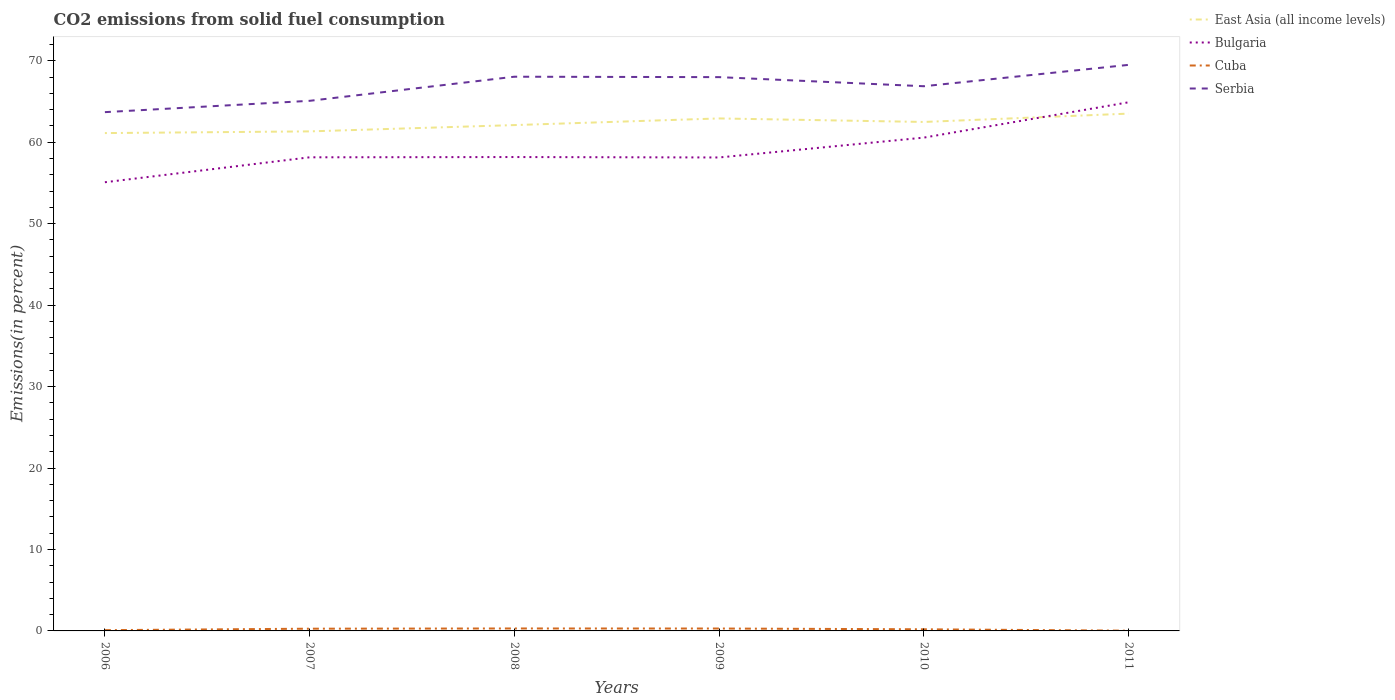How many different coloured lines are there?
Keep it short and to the point. 4. Is the number of lines equal to the number of legend labels?
Your response must be concise. Yes. Across all years, what is the maximum total CO2 emitted in Cuba?
Your response must be concise. 0.03. What is the total total CO2 emitted in Serbia in the graph?
Offer a very short reply. 1.12. What is the difference between the highest and the second highest total CO2 emitted in Cuba?
Provide a succinct answer. 0.27. How many lines are there?
Give a very brief answer. 4. How many years are there in the graph?
Make the answer very short. 6. What is the difference between two consecutive major ticks on the Y-axis?
Make the answer very short. 10. Are the values on the major ticks of Y-axis written in scientific E-notation?
Give a very brief answer. No. Does the graph contain grids?
Offer a terse response. No. Where does the legend appear in the graph?
Ensure brevity in your answer.  Top right. How many legend labels are there?
Provide a succinct answer. 4. How are the legend labels stacked?
Offer a terse response. Vertical. What is the title of the graph?
Offer a very short reply. CO2 emissions from solid fuel consumption. Does "Channel Islands" appear as one of the legend labels in the graph?
Give a very brief answer. No. What is the label or title of the X-axis?
Your response must be concise. Years. What is the label or title of the Y-axis?
Offer a very short reply. Emissions(in percent). What is the Emissions(in percent) in East Asia (all income levels) in 2006?
Keep it short and to the point. 61.12. What is the Emissions(in percent) in Bulgaria in 2006?
Provide a succinct answer. 55.08. What is the Emissions(in percent) of Cuba in 2006?
Make the answer very short. 0.09. What is the Emissions(in percent) of Serbia in 2006?
Your answer should be very brief. 63.69. What is the Emissions(in percent) of East Asia (all income levels) in 2007?
Your response must be concise. 61.33. What is the Emissions(in percent) of Bulgaria in 2007?
Your response must be concise. 58.14. What is the Emissions(in percent) in Cuba in 2007?
Offer a very short reply. 0.27. What is the Emissions(in percent) in Serbia in 2007?
Provide a short and direct response. 65.08. What is the Emissions(in percent) in East Asia (all income levels) in 2008?
Give a very brief answer. 62.1. What is the Emissions(in percent) in Bulgaria in 2008?
Your answer should be compact. 58.18. What is the Emissions(in percent) in Cuba in 2008?
Ensure brevity in your answer.  0.3. What is the Emissions(in percent) of Serbia in 2008?
Offer a terse response. 68.04. What is the Emissions(in percent) in East Asia (all income levels) in 2009?
Offer a very short reply. 62.92. What is the Emissions(in percent) in Bulgaria in 2009?
Your answer should be compact. 58.12. What is the Emissions(in percent) of Cuba in 2009?
Keep it short and to the point. 0.29. What is the Emissions(in percent) of Serbia in 2009?
Offer a very short reply. 67.99. What is the Emissions(in percent) in East Asia (all income levels) in 2010?
Provide a short and direct response. 62.48. What is the Emissions(in percent) of Bulgaria in 2010?
Your response must be concise. 60.56. What is the Emissions(in percent) of Cuba in 2010?
Keep it short and to the point. 0.2. What is the Emissions(in percent) in Serbia in 2010?
Offer a terse response. 66.87. What is the Emissions(in percent) of East Asia (all income levels) in 2011?
Offer a terse response. 63.51. What is the Emissions(in percent) of Bulgaria in 2011?
Your answer should be compact. 64.9. What is the Emissions(in percent) in Cuba in 2011?
Offer a terse response. 0.03. What is the Emissions(in percent) of Serbia in 2011?
Ensure brevity in your answer.  69.49. Across all years, what is the maximum Emissions(in percent) of East Asia (all income levels)?
Offer a terse response. 63.51. Across all years, what is the maximum Emissions(in percent) of Bulgaria?
Your answer should be very brief. 64.9. Across all years, what is the maximum Emissions(in percent) of Cuba?
Give a very brief answer. 0.3. Across all years, what is the maximum Emissions(in percent) in Serbia?
Offer a very short reply. 69.49. Across all years, what is the minimum Emissions(in percent) of East Asia (all income levels)?
Offer a terse response. 61.12. Across all years, what is the minimum Emissions(in percent) of Bulgaria?
Offer a terse response. 55.08. Across all years, what is the minimum Emissions(in percent) of Cuba?
Ensure brevity in your answer.  0.03. Across all years, what is the minimum Emissions(in percent) of Serbia?
Ensure brevity in your answer.  63.69. What is the total Emissions(in percent) of East Asia (all income levels) in the graph?
Make the answer very short. 373.45. What is the total Emissions(in percent) in Bulgaria in the graph?
Offer a very short reply. 354.99. What is the total Emissions(in percent) of Cuba in the graph?
Make the answer very short. 1.19. What is the total Emissions(in percent) of Serbia in the graph?
Offer a terse response. 401.15. What is the difference between the Emissions(in percent) of East Asia (all income levels) in 2006 and that in 2007?
Your answer should be very brief. -0.21. What is the difference between the Emissions(in percent) in Bulgaria in 2006 and that in 2007?
Offer a very short reply. -3.06. What is the difference between the Emissions(in percent) of Cuba in 2006 and that in 2007?
Ensure brevity in your answer.  -0.18. What is the difference between the Emissions(in percent) of Serbia in 2006 and that in 2007?
Ensure brevity in your answer.  -1.39. What is the difference between the Emissions(in percent) in East Asia (all income levels) in 2006 and that in 2008?
Give a very brief answer. -0.98. What is the difference between the Emissions(in percent) in Bulgaria in 2006 and that in 2008?
Ensure brevity in your answer.  -3.09. What is the difference between the Emissions(in percent) in Cuba in 2006 and that in 2008?
Provide a short and direct response. -0.21. What is the difference between the Emissions(in percent) of Serbia in 2006 and that in 2008?
Provide a succinct answer. -4.35. What is the difference between the Emissions(in percent) of East Asia (all income levels) in 2006 and that in 2009?
Keep it short and to the point. -1.8. What is the difference between the Emissions(in percent) of Bulgaria in 2006 and that in 2009?
Keep it short and to the point. -3.04. What is the difference between the Emissions(in percent) of Cuba in 2006 and that in 2009?
Provide a short and direct response. -0.2. What is the difference between the Emissions(in percent) in Serbia in 2006 and that in 2009?
Give a very brief answer. -4.3. What is the difference between the Emissions(in percent) of East Asia (all income levels) in 2006 and that in 2010?
Provide a succinct answer. -1.37. What is the difference between the Emissions(in percent) in Bulgaria in 2006 and that in 2010?
Your answer should be compact. -5.48. What is the difference between the Emissions(in percent) in Cuba in 2006 and that in 2010?
Provide a short and direct response. -0.11. What is the difference between the Emissions(in percent) of Serbia in 2006 and that in 2010?
Your response must be concise. -3.18. What is the difference between the Emissions(in percent) of East Asia (all income levels) in 2006 and that in 2011?
Keep it short and to the point. -2.39. What is the difference between the Emissions(in percent) of Bulgaria in 2006 and that in 2011?
Ensure brevity in your answer.  -9.81. What is the difference between the Emissions(in percent) in Cuba in 2006 and that in 2011?
Offer a very short reply. 0.06. What is the difference between the Emissions(in percent) of Serbia in 2006 and that in 2011?
Provide a succinct answer. -5.8. What is the difference between the Emissions(in percent) of East Asia (all income levels) in 2007 and that in 2008?
Offer a terse response. -0.77. What is the difference between the Emissions(in percent) in Bulgaria in 2007 and that in 2008?
Your answer should be compact. -0.03. What is the difference between the Emissions(in percent) of Cuba in 2007 and that in 2008?
Provide a short and direct response. -0.03. What is the difference between the Emissions(in percent) of Serbia in 2007 and that in 2008?
Provide a short and direct response. -2.96. What is the difference between the Emissions(in percent) of East Asia (all income levels) in 2007 and that in 2009?
Offer a terse response. -1.59. What is the difference between the Emissions(in percent) in Bulgaria in 2007 and that in 2009?
Give a very brief answer. 0.02. What is the difference between the Emissions(in percent) in Cuba in 2007 and that in 2009?
Ensure brevity in your answer.  -0.02. What is the difference between the Emissions(in percent) in Serbia in 2007 and that in 2009?
Offer a very short reply. -2.91. What is the difference between the Emissions(in percent) in East Asia (all income levels) in 2007 and that in 2010?
Your answer should be compact. -1.16. What is the difference between the Emissions(in percent) in Bulgaria in 2007 and that in 2010?
Provide a succinct answer. -2.42. What is the difference between the Emissions(in percent) in Cuba in 2007 and that in 2010?
Your answer should be very brief. 0.07. What is the difference between the Emissions(in percent) in Serbia in 2007 and that in 2010?
Keep it short and to the point. -1.79. What is the difference between the Emissions(in percent) of East Asia (all income levels) in 2007 and that in 2011?
Provide a succinct answer. -2.18. What is the difference between the Emissions(in percent) of Bulgaria in 2007 and that in 2011?
Your answer should be very brief. -6.75. What is the difference between the Emissions(in percent) in Cuba in 2007 and that in 2011?
Give a very brief answer. 0.24. What is the difference between the Emissions(in percent) in Serbia in 2007 and that in 2011?
Provide a succinct answer. -4.41. What is the difference between the Emissions(in percent) of East Asia (all income levels) in 2008 and that in 2009?
Provide a short and direct response. -0.82. What is the difference between the Emissions(in percent) of Bulgaria in 2008 and that in 2009?
Your answer should be very brief. 0.05. What is the difference between the Emissions(in percent) in Cuba in 2008 and that in 2009?
Provide a succinct answer. 0.01. What is the difference between the Emissions(in percent) in Serbia in 2008 and that in 2009?
Make the answer very short. 0.05. What is the difference between the Emissions(in percent) in East Asia (all income levels) in 2008 and that in 2010?
Your answer should be very brief. -0.38. What is the difference between the Emissions(in percent) of Bulgaria in 2008 and that in 2010?
Ensure brevity in your answer.  -2.39. What is the difference between the Emissions(in percent) in Cuba in 2008 and that in 2010?
Give a very brief answer. 0.1. What is the difference between the Emissions(in percent) in Serbia in 2008 and that in 2010?
Your answer should be very brief. 1.17. What is the difference between the Emissions(in percent) of East Asia (all income levels) in 2008 and that in 2011?
Your response must be concise. -1.41. What is the difference between the Emissions(in percent) in Bulgaria in 2008 and that in 2011?
Your answer should be compact. -6.72. What is the difference between the Emissions(in percent) of Cuba in 2008 and that in 2011?
Your response must be concise. 0.27. What is the difference between the Emissions(in percent) of Serbia in 2008 and that in 2011?
Provide a succinct answer. -1.45. What is the difference between the Emissions(in percent) in East Asia (all income levels) in 2009 and that in 2010?
Your answer should be compact. 0.43. What is the difference between the Emissions(in percent) of Bulgaria in 2009 and that in 2010?
Your response must be concise. -2.44. What is the difference between the Emissions(in percent) in Cuba in 2009 and that in 2010?
Offer a terse response. 0.09. What is the difference between the Emissions(in percent) in Serbia in 2009 and that in 2010?
Ensure brevity in your answer.  1.12. What is the difference between the Emissions(in percent) of East Asia (all income levels) in 2009 and that in 2011?
Your answer should be very brief. -0.59. What is the difference between the Emissions(in percent) in Bulgaria in 2009 and that in 2011?
Offer a terse response. -6.77. What is the difference between the Emissions(in percent) in Cuba in 2009 and that in 2011?
Your answer should be very brief. 0.26. What is the difference between the Emissions(in percent) of Serbia in 2009 and that in 2011?
Provide a succinct answer. -1.51. What is the difference between the Emissions(in percent) in East Asia (all income levels) in 2010 and that in 2011?
Keep it short and to the point. -1.02. What is the difference between the Emissions(in percent) of Bulgaria in 2010 and that in 2011?
Offer a terse response. -4.34. What is the difference between the Emissions(in percent) of Cuba in 2010 and that in 2011?
Provide a short and direct response. 0.17. What is the difference between the Emissions(in percent) of Serbia in 2010 and that in 2011?
Make the answer very short. -2.62. What is the difference between the Emissions(in percent) of East Asia (all income levels) in 2006 and the Emissions(in percent) of Bulgaria in 2007?
Offer a terse response. 2.97. What is the difference between the Emissions(in percent) in East Asia (all income levels) in 2006 and the Emissions(in percent) in Cuba in 2007?
Ensure brevity in your answer.  60.84. What is the difference between the Emissions(in percent) in East Asia (all income levels) in 2006 and the Emissions(in percent) in Serbia in 2007?
Offer a terse response. -3.96. What is the difference between the Emissions(in percent) of Bulgaria in 2006 and the Emissions(in percent) of Cuba in 2007?
Make the answer very short. 54.81. What is the difference between the Emissions(in percent) in Bulgaria in 2006 and the Emissions(in percent) in Serbia in 2007?
Offer a very short reply. -9.99. What is the difference between the Emissions(in percent) in Cuba in 2006 and the Emissions(in percent) in Serbia in 2007?
Provide a short and direct response. -64.98. What is the difference between the Emissions(in percent) in East Asia (all income levels) in 2006 and the Emissions(in percent) in Bulgaria in 2008?
Offer a very short reply. 2.94. What is the difference between the Emissions(in percent) in East Asia (all income levels) in 2006 and the Emissions(in percent) in Cuba in 2008?
Offer a very short reply. 60.82. What is the difference between the Emissions(in percent) in East Asia (all income levels) in 2006 and the Emissions(in percent) in Serbia in 2008?
Your response must be concise. -6.92. What is the difference between the Emissions(in percent) of Bulgaria in 2006 and the Emissions(in percent) of Cuba in 2008?
Your answer should be very brief. 54.78. What is the difference between the Emissions(in percent) in Bulgaria in 2006 and the Emissions(in percent) in Serbia in 2008?
Your answer should be compact. -12.95. What is the difference between the Emissions(in percent) in Cuba in 2006 and the Emissions(in percent) in Serbia in 2008?
Provide a short and direct response. -67.94. What is the difference between the Emissions(in percent) of East Asia (all income levels) in 2006 and the Emissions(in percent) of Bulgaria in 2009?
Your answer should be very brief. 2.99. What is the difference between the Emissions(in percent) in East Asia (all income levels) in 2006 and the Emissions(in percent) in Cuba in 2009?
Make the answer very short. 60.82. What is the difference between the Emissions(in percent) in East Asia (all income levels) in 2006 and the Emissions(in percent) in Serbia in 2009?
Offer a very short reply. -6.87. What is the difference between the Emissions(in percent) of Bulgaria in 2006 and the Emissions(in percent) of Cuba in 2009?
Give a very brief answer. 54.79. What is the difference between the Emissions(in percent) of Bulgaria in 2006 and the Emissions(in percent) of Serbia in 2009?
Your response must be concise. -12.9. What is the difference between the Emissions(in percent) in Cuba in 2006 and the Emissions(in percent) in Serbia in 2009?
Provide a short and direct response. -67.89. What is the difference between the Emissions(in percent) in East Asia (all income levels) in 2006 and the Emissions(in percent) in Bulgaria in 2010?
Offer a very short reply. 0.56. What is the difference between the Emissions(in percent) in East Asia (all income levels) in 2006 and the Emissions(in percent) in Cuba in 2010?
Provide a succinct answer. 60.92. What is the difference between the Emissions(in percent) of East Asia (all income levels) in 2006 and the Emissions(in percent) of Serbia in 2010?
Offer a very short reply. -5.75. What is the difference between the Emissions(in percent) of Bulgaria in 2006 and the Emissions(in percent) of Cuba in 2010?
Provide a succinct answer. 54.88. What is the difference between the Emissions(in percent) of Bulgaria in 2006 and the Emissions(in percent) of Serbia in 2010?
Give a very brief answer. -11.79. What is the difference between the Emissions(in percent) of Cuba in 2006 and the Emissions(in percent) of Serbia in 2010?
Your response must be concise. -66.78. What is the difference between the Emissions(in percent) of East Asia (all income levels) in 2006 and the Emissions(in percent) of Bulgaria in 2011?
Make the answer very short. -3.78. What is the difference between the Emissions(in percent) in East Asia (all income levels) in 2006 and the Emissions(in percent) in Cuba in 2011?
Provide a short and direct response. 61.09. What is the difference between the Emissions(in percent) in East Asia (all income levels) in 2006 and the Emissions(in percent) in Serbia in 2011?
Provide a short and direct response. -8.37. What is the difference between the Emissions(in percent) of Bulgaria in 2006 and the Emissions(in percent) of Cuba in 2011?
Keep it short and to the point. 55.05. What is the difference between the Emissions(in percent) of Bulgaria in 2006 and the Emissions(in percent) of Serbia in 2011?
Provide a short and direct response. -14.41. What is the difference between the Emissions(in percent) of Cuba in 2006 and the Emissions(in percent) of Serbia in 2011?
Give a very brief answer. -69.4. What is the difference between the Emissions(in percent) in East Asia (all income levels) in 2007 and the Emissions(in percent) in Bulgaria in 2008?
Ensure brevity in your answer.  3.15. What is the difference between the Emissions(in percent) in East Asia (all income levels) in 2007 and the Emissions(in percent) in Cuba in 2008?
Your answer should be very brief. 61.02. What is the difference between the Emissions(in percent) of East Asia (all income levels) in 2007 and the Emissions(in percent) of Serbia in 2008?
Ensure brevity in your answer.  -6.71. What is the difference between the Emissions(in percent) in Bulgaria in 2007 and the Emissions(in percent) in Cuba in 2008?
Offer a terse response. 57.84. What is the difference between the Emissions(in percent) of Bulgaria in 2007 and the Emissions(in percent) of Serbia in 2008?
Your answer should be very brief. -9.89. What is the difference between the Emissions(in percent) in Cuba in 2007 and the Emissions(in percent) in Serbia in 2008?
Provide a succinct answer. -67.76. What is the difference between the Emissions(in percent) of East Asia (all income levels) in 2007 and the Emissions(in percent) of Bulgaria in 2009?
Provide a succinct answer. 3.2. What is the difference between the Emissions(in percent) of East Asia (all income levels) in 2007 and the Emissions(in percent) of Cuba in 2009?
Provide a short and direct response. 61.03. What is the difference between the Emissions(in percent) of East Asia (all income levels) in 2007 and the Emissions(in percent) of Serbia in 2009?
Offer a very short reply. -6.66. What is the difference between the Emissions(in percent) in Bulgaria in 2007 and the Emissions(in percent) in Cuba in 2009?
Keep it short and to the point. 57.85. What is the difference between the Emissions(in percent) in Bulgaria in 2007 and the Emissions(in percent) in Serbia in 2009?
Your answer should be very brief. -9.84. What is the difference between the Emissions(in percent) in Cuba in 2007 and the Emissions(in percent) in Serbia in 2009?
Give a very brief answer. -67.71. What is the difference between the Emissions(in percent) in East Asia (all income levels) in 2007 and the Emissions(in percent) in Bulgaria in 2010?
Keep it short and to the point. 0.76. What is the difference between the Emissions(in percent) in East Asia (all income levels) in 2007 and the Emissions(in percent) in Cuba in 2010?
Your response must be concise. 61.12. What is the difference between the Emissions(in percent) of East Asia (all income levels) in 2007 and the Emissions(in percent) of Serbia in 2010?
Your answer should be compact. -5.54. What is the difference between the Emissions(in percent) in Bulgaria in 2007 and the Emissions(in percent) in Cuba in 2010?
Give a very brief answer. 57.94. What is the difference between the Emissions(in percent) of Bulgaria in 2007 and the Emissions(in percent) of Serbia in 2010?
Make the answer very short. -8.73. What is the difference between the Emissions(in percent) of Cuba in 2007 and the Emissions(in percent) of Serbia in 2010?
Make the answer very short. -66.6. What is the difference between the Emissions(in percent) of East Asia (all income levels) in 2007 and the Emissions(in percent) of Bulgaria in 2011?
Your answer should be compact. -3.57. What is the difference between the Emissions(in percent) in East Asia (all income levels) in 2007 and the Emissions(in percent) in Cuba in 2011?
Provide a short and direct response. 61.3. What is the difference between the Emissions(in percent) of East Asia (all income levels) in 2007 and the Emissions(in percent) of Serbia in 2011?
Provide a succinct answer. -8.17. What is the difference between the Emissions(in percent) of Bulgaria in 2007 and the Emissions(in percent) of Cuba in 2011?
Your response must be concise. 58.11. What is the difference between the Emissions(in percent) in Bulgaria in 2007 and the Emissions(in percent) in Serbia in 2011?
Provide a succinct answer. -11.35. What is the difference between the Emissions(in percent) in Cuba in 2007 and the Emissions(in percent) in Serbia in 2011?
Provide a short and direct response. -69.22. What is the difference between the Emissions(in percent) in East Asia (all income levels) in 2008 and the Emissions(in percent) in Bulgaria in 2009?
Give a very brief answer. 3.98. What is the difference between the Emissions(in percent) of East Asia (all income levels) in 2008 and the Emissions(in percent) of Cuba in 2009?
Your answer should be very brief. 61.81. What is the difference between the Emissions(in percent) in East Asia (all income levels) in 2008 and the Emissions(in percent) in Serbia in 2009?
Ensure brevity in your answer.  -5.89. What is the difference between the Emissions(in percent) of Bulgaria in 2008 and the Emissions(in percent) of Cuba in 2009?
Offer a very short reply. 57.88. What is the difference between the Emissions(in percent) of Bulgaria in 2008 and the Emissions(in percent) of Serbia in 2009?
Provide a short and direct response. -9.81. What is the difference between the Emissions(in percent) in Cuba in 2008 and the Emissions(in percent) in Serbia in 2009?
Offer a very short reply. -67.69. What is the difference between the Emissions(in percent) of East Asia (all income levels) in 2008 and the Emissions(in percent) of Bulgaria in 2010?
Your answer should be compact. 1.54. What is the difference between the Emissions(in percent) of East Asia (all income levels) in 2008 and the Emissions(in percent) of Cuba in 2010?
Your answer should be compact. 61.9. What is the difference between the Emissions(in percent) of East Asia (all income levels) in 2008 and the Emissions(in percent) of Serbia in 2010?
Your answer should be compact. -4.77. What is the difference between the Emissions(in percent) in Bulgaria in 2008 and the Emissions(in percent) in Cuba in 2010?
Offer a terse response. 57.98. What is the difference between the Emissions(in percent) in Bulgaria in 2008 and the Emissions(in percent) in Serbia in 2010?
Make the answer very short. -8.69. What is the difference between the Emissions(in percent) of Cuba in 2008 and the Emissions(in percent) of Serbia in 2010?
Provide a succinct answer. -66.57. What is the difference between the Emissions(in percent) of East Asia (all income levels) in 2008 and the Emissions(in percent) of Bulgaria in 2011?
Your answer should be very brief. -2.8. What is the difference between the Emissions(in percent) in East Asia (all income levels) in 2008 and the Emissions(in percent) in Cuba in 2011?
Provide a succinct answer. 62.07. What is the difference between the Emissions(in percent) of East Asia (all income levels) in 2008 and the Emissions(in percent) of Serbia in 2011?
Offer a terse response. -7.39. What is the difference between the Emissions(in percent) of Bulgaria in 2008 and the Emissions(in percent) of Cuba in 2011?
Your response must be concise. 58.15. What is the difference between the Emissions(in percent) in Bulgaria in 2008 and the Emissions(in percent) in Serbia in 2011?
Offer a terse response. -11.32. What is the difference between the Emissions(in percent) in Cuba in 2008 and the Emissions(in percent) in Serbia in 2011?
Ensure brevity in your answer.  -69.19. What is the difference between the Emissions(in percent) in East Asia (all income levels) in 2009 and the Emissions(in percent) in Bulgaria in 2010?
Offer a very short reply. 2.35. What is the difference between the Emissions(in percent) in East Asia (all income levels) in 2009 and the Emissions(in percent) in Cuba in 2010?
Give a very brief answer. 62.71. What is the difference between the Emissions(in percent) of East Asia (all income levels) in 2009 and the Emissions(in percent) of Serbia in 2010?
Give a very brief answer. -3.95. What is the difference between the Emissions(in percent) of Bulgaria in 2009 and the Emissions(in percent) of Cuba in 2010?
Give a very brief answer. 57.92. What is the difference between the Emissions(in percent) of Bulgaria in 2009 and the Emissions(in percent) of Serbia in 2010?
Your answer should be very brief. -8.74. What is the difference between the Emissions(in percent) of Cuba in 2009 and the Emissions(in percent) of Serbia in 2010?
Your answer should be very brief. -66.57. What is the difference between the Emissions(in percent) of East Asia (all income levels) in 2009 and the Emissions(in percent) of Bulgaria in 2011?
Provide a succinct answer. -1.98. What is the difference between the Emissions(in percent) of East Asia (all income levels) in 2009 and the Emissions(in percent) of Cuba in 2011?
Offer a terse response. 62.88. What is the difference between the Emissions(in percent) of East Asia (all income levels) in 2009 and the Emissions(in percent) of Serbia in 2011?
Keep it short and to the point. -6.58. What is the difference between the Emissions(in percent) of Bulgaria in 2009 and the Emissions(in percent) of Cuba in 2011?
Offer a terse response. 58.09. What is the difference between the Emissions(in percent) in Bulgaria in 2009 and the Emissions(in percent) in Serbia in 2011?
Offer a very short reply. -11.37. What is the difference between the Emissions(in percent) in Cuba in 2009 and the Emissions(in percent) in Serbia in 2011?
Offer a very short reply. -69.2. What is the difference between the Emissions(in percent) of East Asia (all income levels) in 2010 and the Emissions(in percent) of Bulgaria in 2011?
Your response must be concise. -2.41. What is the difference between the Emissions(in percent) of East Asia (all income levels) in 2010 and the Emissions(in percent) of Cuba in 2011?
Your response must be concise. 62.45. What is the difference between the Emissions(in percent) in East Asia (all income levels) in 2010 and the Emissions(in percent) in Serbia in 2011?
Your response must be concise. -7.01. What is the difference between the Emissions(in percent) in Bulgaria in 2010 and the Emissions(in percent) in Cuba in 2011?
Provide a short and direct response. 60.53. What is the difference between the Emissions(in percent) of Bulgaria in 2010 and the Emissions(in percent) of Serbia in 2011?
Your answer should be compact. -8.93. What is the difference between the Emissions(in percent) of Cuba in 2010 and the Emissions(in percent) of Serbia in 2011?
Make the answer very short. -69.29. What is the average Emissions(in percent) in East Asia (all income levels) per year?
Give a very brief answer. 62.24. What is the average Emissions(in percent) in Bulgaria per year?
Your answer should be very brief. 59.16. What is the average Emissions(in percent) of Cuba per year?
Your answer should be very brief. 0.2. What is the average Emissions(in percent) in Serbia per year?
Your response must be concise. 66.86. In the year 2006, what is the difference between the Emissions(in percent) in East Asia (all income levels) and Emissions(in percent) in Bulgaria?
Offer a terse response. 6.03. In the year 2006, what is the difference between the Emissions(in percent) in East Asia (all income levels) and Emissions(in percent) in Cuba?
Offer a very short reply. 61.02. In the year 2006, what is the difference between the Emissions(in percent) of East Asia (all income levels) and Emissions(in percent) of Serbia?
Provide a succinct answer. -2.57. In the year 2006, what is the difference between the Emissions(in percent) of Bulgaria and Emissions(in percent) of Cuba?
Offer a very short reply. 54.99. In the year 2006, what is the difference between the Emissions(in percent) of Bulgaria and Emissions(in percent) of Serbia?
Make the answer very short. -8.6. In the year 2006, what is the difference between the Emissions(in percent) of Cuba and Emissions(in percent) of Serbia?
Keep it short and to the point. -63.59. In the year 2007, what is the difference between the Emissions(in percent) in East Asia (all income levels) and Emissions(in percent) in Bulgaria?
Provide a succinct answer. 3.18. In the year 2007, what is the difference between the Emissions(in percent) in East Asia (all income levels) and Emissions(in percent) in Cuba?
Give a very brief answer. 61.05. In the year 2007, what is the difference between the Emissions(in percent) of East Asia (all income levels) and Emissions(in percent) of Serbia?
Offer a very short reply. -3.75. In the year 2007, what is the difference between the Emissions(in percent) of Bulgaria and Emissions(in percent) of Cuba?
Provide a succinct answer. 57.87. In the year 2007, what is the difference between the Emissions(in percent) in Bulgaria and Emissions(in percent) in Serbia?
Provide a succinct answer. -6.93. In the year 2007, what is the difference between the Emissions(in percent) in Cuba and Emissions(in percent) in Serbia?
Make the answer very short. -64.8. In the year 2008, what is the difference between the Emissions(in percent) in East Asia (all income levels) and Emissions(in percent) in Bulgaria?
Your answer should be compact. 3.92. In the year 2008, what is the difference between the Emissions(in percent) of East Asia (all income levels) and Emissions(in percent) of Cuba?
Ensure brevity in your answer.  61.8. In the year 2008, what is the difference between the Emissions(in percent) of East Asia (all income levels) and Emissions(in percent) of Serbia?
Provide a succinct answer. -5.94. In the year 2008, what is the difference between the Emissions(in percent) in Bulgaria and Emissions(in percent) in Cuba?
Your answer should be very brief. 57.88. In the year 2008, what is the difference between the Emissions(in percent) in Bulgaria and Emissions(in percent) in Serbia?
Make the answer very short. -9.86. In the year 2008, what is the difference between the Emissions(in percent) in Cuba and Emissions(in percent) in Serbia?
Provide a succinct answer. -67.74. In the year 2009, what is the difference between the Emissions(in percent) of East Asia (all income levels) and Emissions(in percent) of Bulgaria?
Make the answer very short. 4.79. In the year 2009, what is the difference between the Emissions(in percent) in East Asia (all income levels) and Emissions(in percent) in Cuba?
Offer a very short reply. 62.62. In the year 2009, what is the difference between the Emissions(in percent) in East Asia (all income levels) and Emissions(in percent) in Serbia?
Offer a terse response. -5.07. In the year 2009, what is the difference between the Emissions(in percent) in Bulgaria and Emissions(in percent) in Cuba?
Ensure brevity in your answer.  57.83. In the year 2009, what is the difference between the Emissions(in percent) of Bulgaria and Emissions(in percent) of Serbia?
Offer a terse response. -9.86. In the year 2009, what is the difference between the Emissions(in percent) of Cuba and Emissions(in percent) of Serbia?
Offer a very short reply. -67.69. In the year 2010, what is the difference between the Emissions(in percent) in East Asia (all income levels) and Emissions(in percent) in Bulgaria?
Your answer should be compact. 1.92. In the year 2010, what is the difference between the Emissions(in percent) of East Asia (all income levels) and Emissions(in percent) of Cuba?
Offer a very short reply. 62.28. In the year 2010, what is the difference between the Emissions(in percent) of East Asia (all income levels) and Emissions(in percent) of Serbia?
Your response must be concise. -4.39. In the year 2010, what is the difference between the Emissions(in percent) of Bulgaria and Emissions(in percent) of Cuba?
Provide a short and direct response. 60.36. In the year 2010, what is the difference between the Emissions(in percent) of Bulgaria and Emissions(in percent) of Serbia?
Your answer should be compact. -6.31. In the year 2010, what is the difference between the Emissions(in percent) of Cuba and Emissions(in percent) of Serbia?
Ensure brevity in your answer.  -66.67. In the year 2011, what is the difference between the Emissions(in percent) of East Asia (all income levels) and Emissions(in percent) of Bulgaria?
Make the answer very short. -1.39. In the year 2011, what is the difference between the Emissions(in percent) in East Asia (all income levels) and Emissions(in percent) in Cuba?
Make the answer very short. 63.48. In the year 2011, what is the difference between the Emissions(in percent) in East Asia (all income levels) and Emissions(in percent) in Serbia?
Keep it short and to the point. -5.98. In the year 2011, what is the difference between the Emissions(in percent) of Bulgaria and Emissions(in percent) of Cuba?
Provide a succinct answer. 64.87. In the year 2011, what is the difference between the Emissions(in percent) of Bulgaria and Emissions(in percent) of Serbia?
Make the answer very short. -4.59. In the year 2011, what is the difference between the Emissions(in percent) in Cuba and Emissions(in percent) in Serbia?
Your response must be concise. -69.46. What is the ratio of the Emissions(in percent) in East Asia (all income levels) in 2006 to that in 2007?
Make the answer very short. 1. What is the ratio of the Emissions(in percent) of Cuba in 2006 to that in 2007?
Provide a short and direct response. 0.34. What is the ratio of the Emissions(in percent) in Serbia in 2006 to that in 2007?
Your answer should be compact. 0.98. What is the ratio of the Emissions(in percent) of East Asia (all income levels) in 2006 to that in 2008?
Make the answer very short. 0.98. What is the ratio of the Emissions(in percent) in Bulgaria in 2006 to that in 2008?
Provide a short and direct response. 0.95. What is the ratio of the Emissions(in percent) in Cuba in 2006 to that in 2008?
Your answer should be very brief. 0.31. What is the ratio of the Emissions(in percent) in Serbia in 2006 to that in 2008?
Provide a short and direct response. 0.94. What is the ratio of the Emissions(in percent) of East Asia (all income levels) in 2006 to that in 2009?
Your answer should be very brief. 0.97. What is the ratio of the Emissions(in percent) in Bulgaria in 2006 to that in 2009?
Make the answer very short. 0.95. What is the ratio of the Emissions(in percent) in Cuba in 2006 to that in 2009?
Your answer should be compact. 0.32. What is the ratio of the Emissions(in percent) in Serbia in 2006 to that in 2009?
Your answer should be compact. 0.94. What is the ratio of the Emissions(in percent) in East Asia (all income levels) in 2006 to that in 2010?
Your response must be concise. 0.98. What is the ratio of the Emissions(in percent) of Bulgaria in 2006 to that in 2010?
Your answer should be compact. 0.91. What is the ratio of the Emissions(in percent) in Cuba in 2006 to that in 2010?
Give a very brief answer. 0.47. What is the ratio of the Emissions(in percent) of East Asia (all income levels) in 2006 to that in 2011?
Provide a short and direct response. 0.96. What is the ratio of the Emissions(in percent) of Bulgaria in 2006 to that in 2011?
Provide a succinct answer. 0.85. What is the ratio of the Emissions(in percent) of Cuba in 2006 to that in 2011?
Give a very brief answer. 3.06. What is the ratio of the Emissions(in percent) in Serbia in 2006 to that in 2011?
Offer a very short reply. 0.92. What is the ratio of the Emissions(in percent) in East Asia (all income levels) in 2007 to that in 2008?
Your answer should be compact. 0.99. What is the ratio of the Emissions(in percent) of Bulgaria in 2007 to that in 2008?
Your answer should be compact. 1. What is the ratio of the Emissions(in percent) of Cuba in 2007 to that in 2008?
Your answer should be very brief. 0.91. What is the ratio of the Emissions(in percent) of Serbia in 2007 to that in 2008?
Offer a very short reply. 0.96. What is the ratio of the Emissions(in percent) of East Asia (all income levels) in 2007 to that in 2009?
Your answer should be compact. 0.97. What is the ratio of the Emissions(in percent) in Bulgaria in 2007 to that in 2009?
Provide a succinct answer. 1. What is the ratio of the Emissions(in percent) of Cuba in 2007 to that in 2009?
Keep it short and to the point. 0.93. What is the ratio of the Emissions(in percent) of Serbia in 2007 to that in 2009?
Provide a succinct answer. 0.96. What is the ratio of the Emissions(in percent) of East Asia (all income levels) in 2007 to that in 2010?
Offer a very short reply. 0.98. What is the ratio of the Emissions(in percent) of Bulgaria in 2007 to that in 2010?
Provide a short and direct response. 0.96. What is the ratio of the Emissions(in percent) of Cuba in 2007 to that in 2010?
Make the answer very short. 1.36. What is the ratio of the Emissions(in percent) of Serbia in 2007 to that in 2010?
Your answer should be compact. 0.97. What is the ratio of the Emissions(in percent) of East Asia (all income levels) in 2007 to that in 2011?
Offer a terse response. 0.97. What is the ratio of the Emissions(in percent) in Bulgaria in 2007 to that in 2011?
Provide a succinct answer. 0.9. What is the ratio of the Emissions(in percent) in Cuba in 2007 to that in 2011?
Provide a short and direct response. 8.94. What is the ratio of the Emissions(in percent) of Serbia in 2007 to that in 2011?
Your answer should be compact. 0.94. What is the ratio of the Emissions(in percent) of Bulgaria in 2008 to that in 2009?
Your answer should be compact. 1. What is the ratio of the Emissions(in percent) in Bulgaria in 2008 to that in 2010?
Provide a succinct answer. 0.96. What is the ratio of the Emissions(in percent) in Cuba in 2008 to that in 2010?
Your answer should be very brief. 1.5. What is the ratio of the Emissions(in percent) in Serbia in 2008 to that in 2010?
Your response must be concise. 1.02. What is the ratio of the Emissions(in percent) in East Asia (all income levels) in 2008 to that in 2011?
Provide a succinct answer. 0.98. What is the ratio of the Emissions(in percent) of Bulgaria in 2008 to that in 2011?
Your response must be concise. 0.9. What is the ratio of the Emissions(in percent) of Cuba in 2008 to that in 2011?
Your answer should be very brief. 9.83. What is the ratio of the Emissions(in percent) of Serbia in 2008 to that in 2011?
Offer a terse response. 0.98. What is the ratio of the Emissions(in percent) of East Asia (all income levels) in 2009 to that in 2010?
Provide a succinct answer. 1.01. What is the ratio of the Emissions(in percent) of Bulgaria in 2009 to that in 2010?
Ensure brevity in your answer.  0.96. What is the ratio of the Emissions(in percent) in Cuba in 2009 to that in 2010?
Your answer should be compact. 1.47. What is the ratio of the Emissions(in percent) in Serbia in 2009 to that in 2010?
Make the answer very short. 1.02. What is the ratio of the Emissions(in percent) in East Asia (all income levels) in 2009 to that in 2011?
Make the answer very short. 0.99. What is the ratio of the Emissions(in percent) in Bulgaria in 2009 to that in 2011?
Make the answer very short. 0.9. What is the ratio of the Emissions(in percent) in Cuba in 2009 to that in 2011?
Provide a succinct answer. 9.61. What is the ratio of the Emissions(in percent) in Serbia in 2009 to that in 2011?
Keep it short and to the point. 0.98. What is the ratio of the Emissions(in percent) of East Asia (all income levels) in 2010 to that in 2011?
Your answer should be very brief. 0.98. What is the ratio of the Emissions(in percent) of Bulgaria in 2010 to that in 2011?
Ensure brevity in your answer.  0.93. What is the ratio of the Emissions(in percent) in Cuba in 2010 to that in 2011?
Offer a terse response. 6.55. What is the ratio of the Emissions(in percent) of Serbia in 2010 to that in 2011?
Keep it short and to the point. 0.96. What is the difference between the highest and the second highest Emissions(in percent) in East Asia (all income levels)?
Offer a terse response. 0.59. What is the difference between the highest and the second highest Emissions(in percent) in Bulgaria?
Make the answer very short. 4.34. What is the difference between the highest and the second highest Emissions(in percent) in Cuba?
Give a very brief answer. 0.01. What is the difference between the highest and the second highest Emissions(in percent) in Serbia?
Your answer should be very brief. 1.45. What is the difference between the highest and the lowest Emissions(in percent) of East Asia (all income levels)?
Provide a succinct answer. 2.39. What is the difference between the highest and the lowest Emissions(in percent) of Bulgaria?
Provide a succinct answer. 9.81. What is the difference between the highest and the lowest Emissions(in percent) in Cuba?
Make the answer very short. 0.27. What is the difference between the highest and the lowest Emissions(in percent) of Serbia?
Provide a succinct answer. 5.8. 